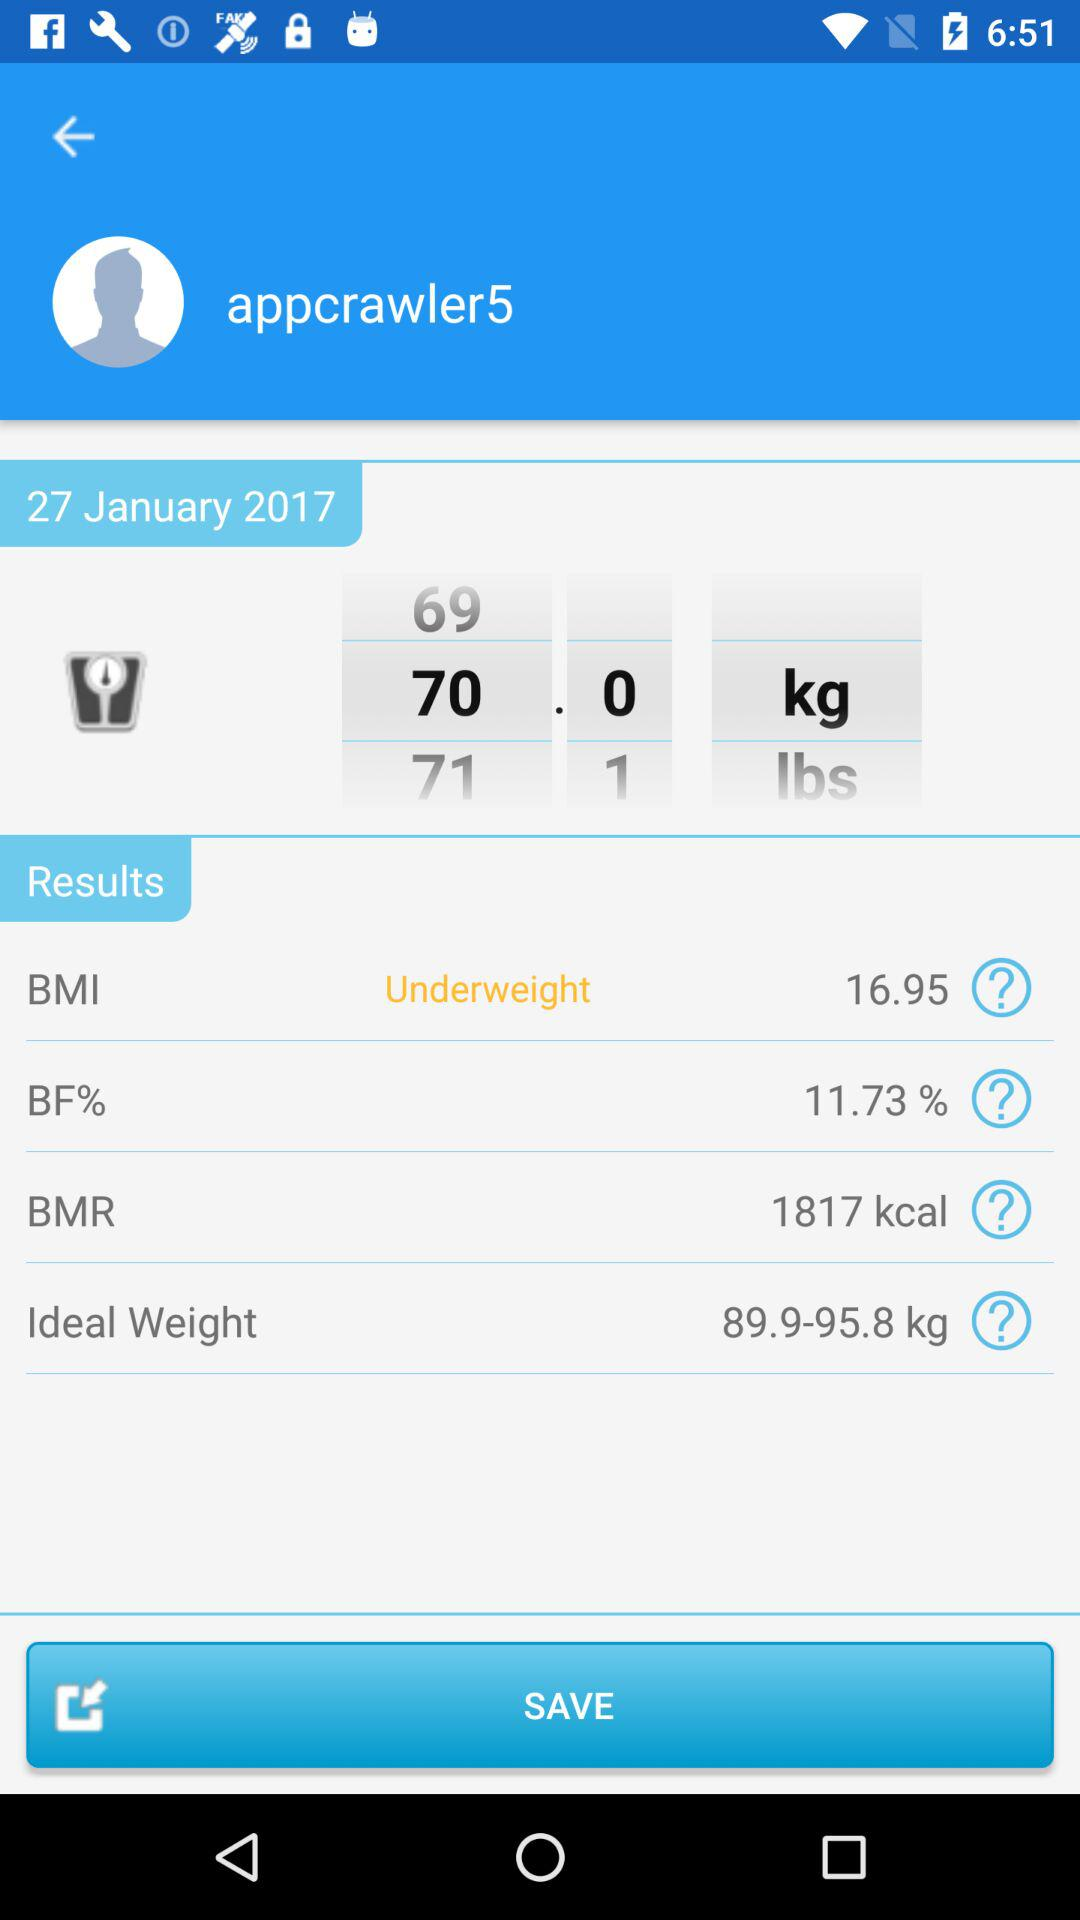What is the BMI? The BMI is 16.95. 